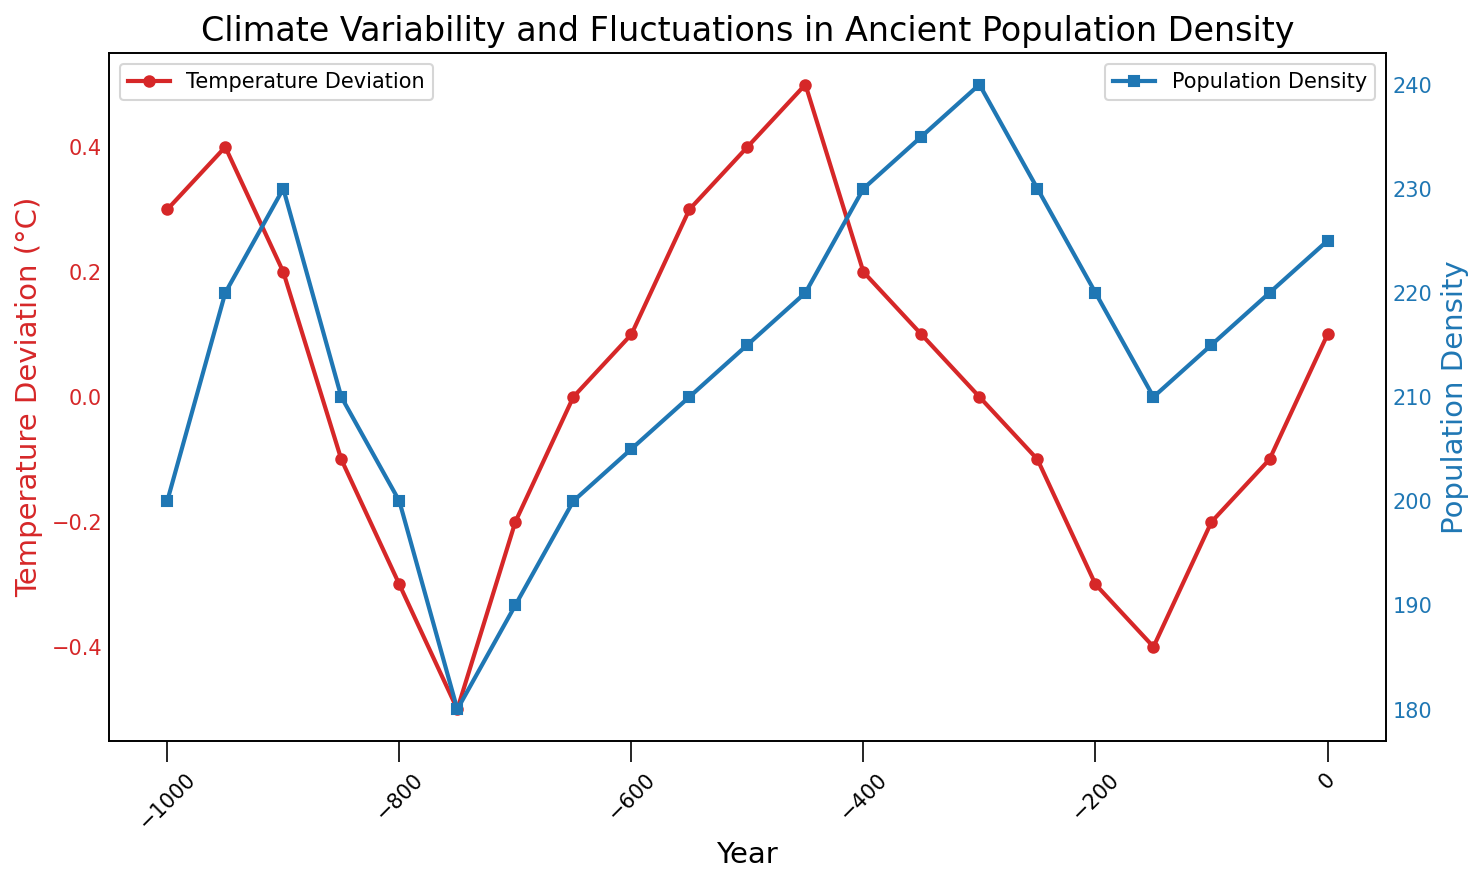How did the population density change between the years -1000 and 0? The population density in the year -1000 was 200 and increased gradually over time to 225 by the year 0. By examining the plotted points for population density, we can see the trend is generally increasing.
Answer: It increased from 200 to 225 During which periods did the temperature deviation show a negative trend? By observing the red line representing temperature deviation, we can see the negative trend between the years -850 and -750 and again from -250 to -150. During these periods, the temperature deviation values decrease.
Answer: -850 to -750 and -250 to -150 What is the difference in population density between the years -750 and -700? The population density in the year -750 was 180, whereas in -700 it was 190. The difference can be calculated as 190 - 180.
Answer: 10 At what point did temperature deviation peak, and what was the corresponding population density? The temperature deviation peaked at the year -450 with a value of 0.5°C. At this point, we can see from the blue line that the population density was 220.
Answer: -450 and 220 Is there a correlation between temperature deviation and population density? Provide specific examples. By observing the plot, there's a slight positive correlation—when the temperature deviation increases, the population density seems to increase. For instance, around -450, both temperature deviation (0.5°C) and population density (220) are high. Conversely, between -800 and -750, both temperature deviation (-0.3°C to -0.5°C) and population density (200 to 180) are low.
Answer: Yes, there is a slight positive correlation What was the temperature deviation in the year -600, and how did it impact population density? The temperature deviation in the year -600 was 0.1°C. The population density at that time was 205. The small positive deviation likely contributed to a stable population density compared to previous years' fluctuations.
Answer: 0.1°C and 205 Which years had a temperature deviation of 0°C and what were the corresponding population densities? From the plot, the temperature deviation of 0°C occurred in the years -650 and -300. Checking the population densities, in -650 it was 200, and in -300, it was 240.
Answer: -650 with 200 and -300 with 240 What trends can be observed in population density when there is a positive temperature deviation? When there is a positive temperature deviation (e.g., 0.3°C at -1000, 0.4°C at -950, 0.5°C at -450), the population density tends to be higher (e.g., 200, 220, 220 respectively). The positive deviation seems to coincide with higher population densities.
Answer: Higher population densities Calculate the average population density from -1000 to -500. The population densities from -1000 to -500 are: 200, 220, 230, 210, 200, 180, 190, 200, 205, 210. Sum these values to get 2045. Divide by the number of values (10) to get the average.
Answer: 204.5 What color represents the temperature deviation line, and what does this suggest about the presentation of data? The temperature deviation is represented by the red line, which makes it distinct and clear against the blue population density line. This choice helps in easily distinguishing between the two datasets.
Answer: Red 